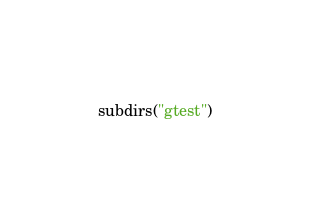<code> <loc_0><loc_0><loc_500><loc_500><_CMake_>subdirs("gtest")
</code> 